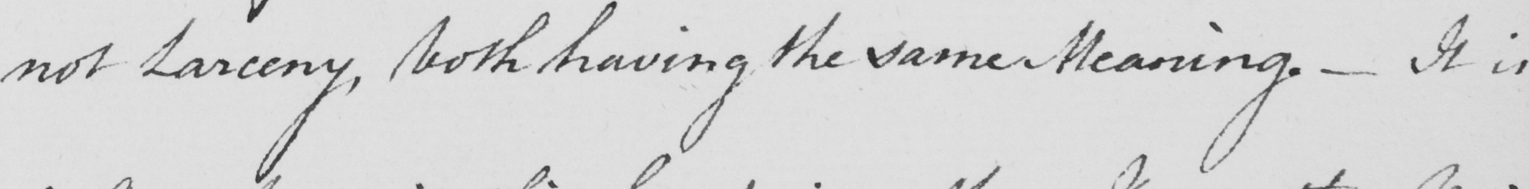What text is written in this handwritten line? not Larceny , both having the same Meaning .  _  It is 